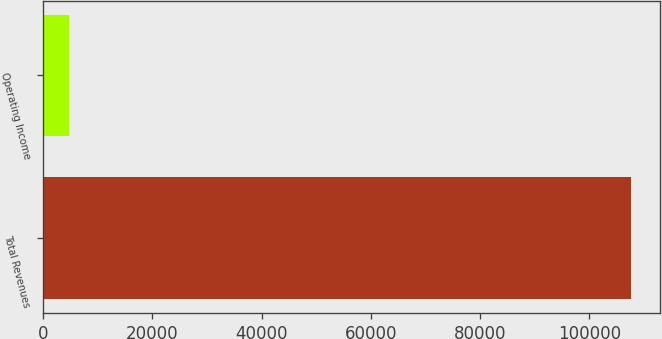Convert chart. <chart><loc_0><loc_0><loc_500><loc_500><bar_chart><fcel>Total Revenues<fcel>Operating Income<nl><fcel>107578<fcel>4742<nl></chart> 